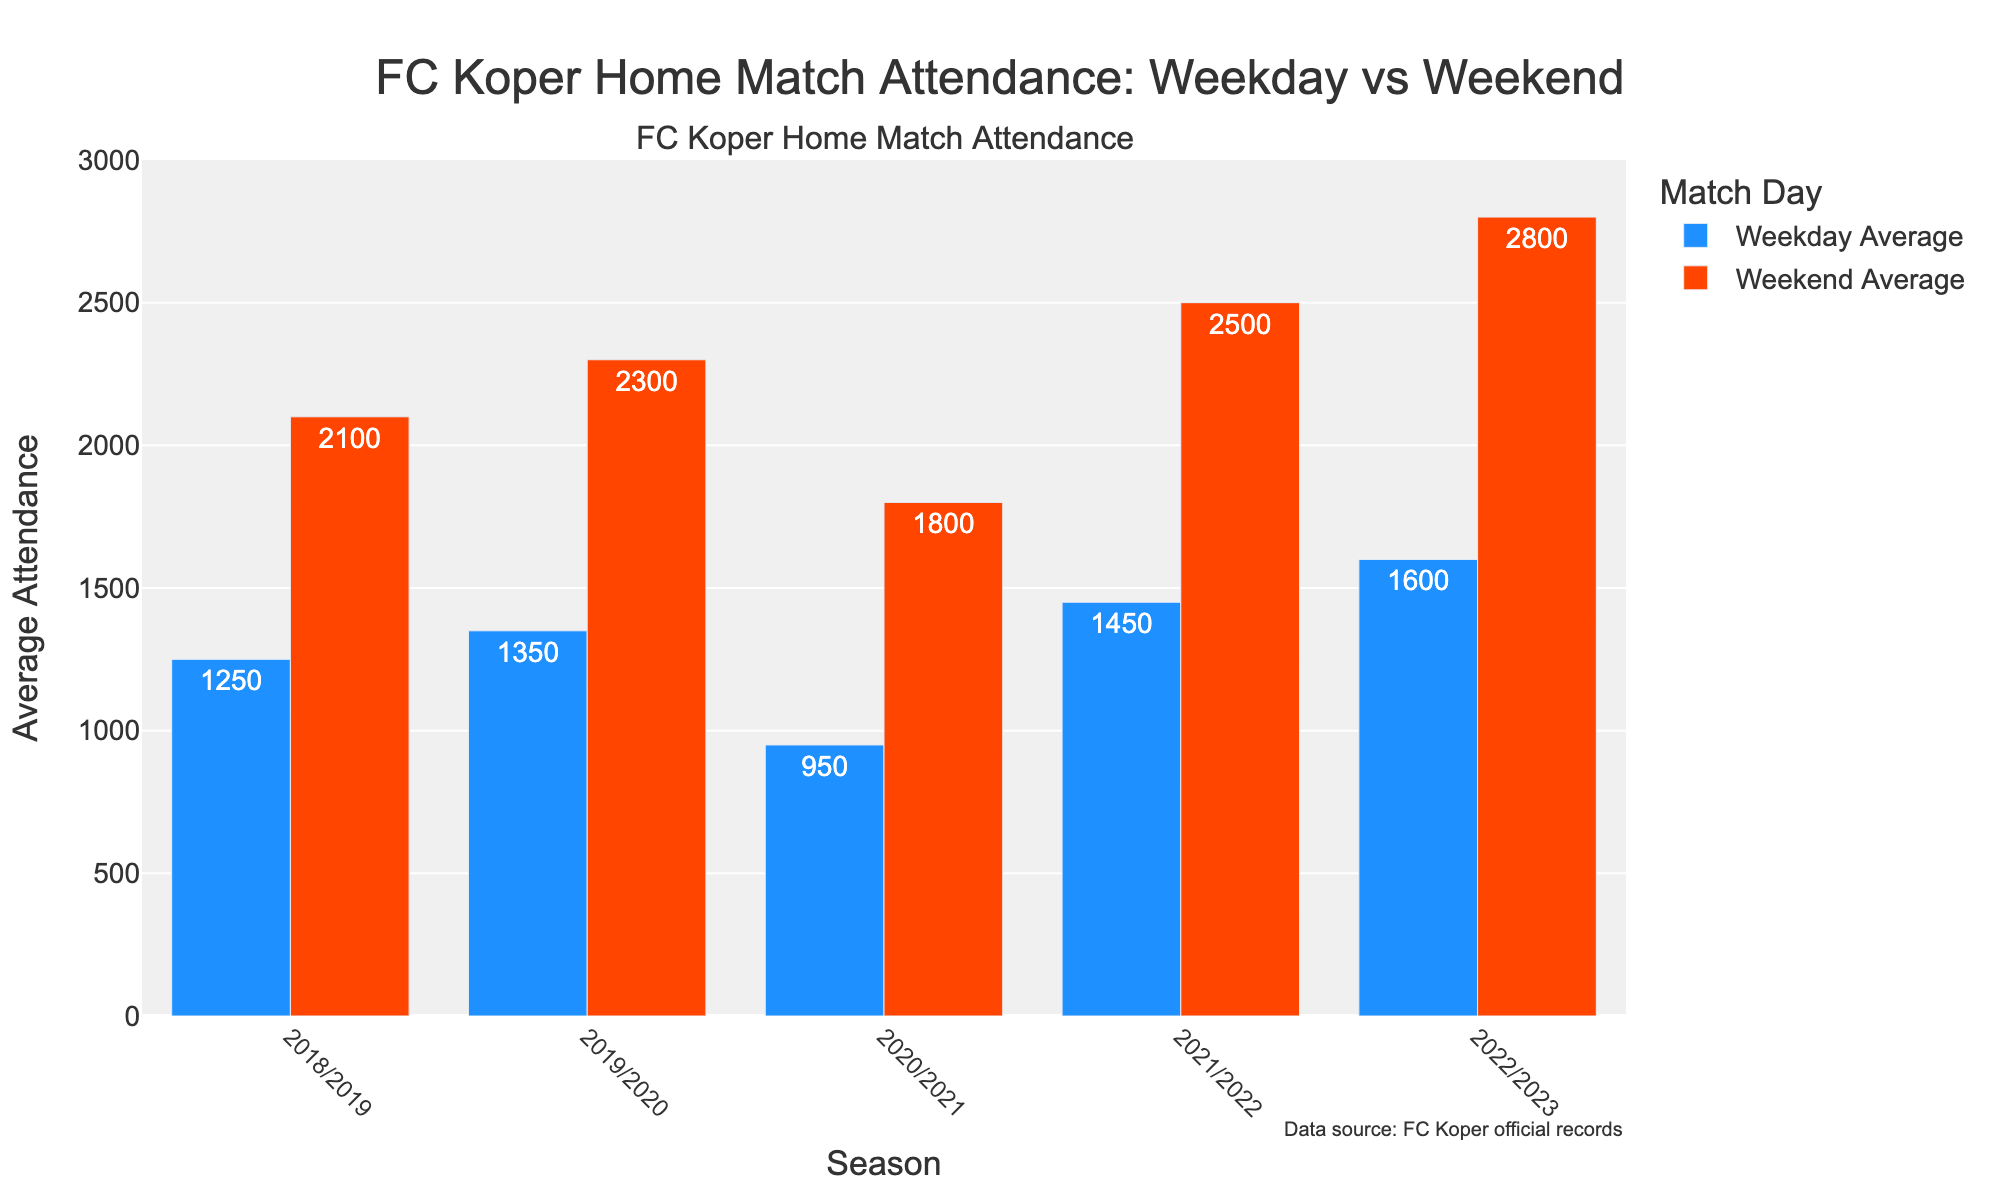What's the average attendance for FC Koper's home matches on weekdays in the 2022/2023 season? The bar corresponding to the 'Weekday Average' for the 2022/2023 season reaches up to 1600.
Answer: 1600 In which season did FC Koper record the highest weekend attendance? By comparing the heights of the 'Weekend Average' bars across all seasons, the 2022/2023 season has the highest bar at 2800.
Answer: 2022/2023 By how much did the weekday average attendance increase from the 2020/2021 to the 2022/2023 season? Subtract the 'Weekday Average' for 2020/2021 (950) from the 'Weekday Average' for 2022/2023 (1600). 1600 - 950 = 650.
Answer: 650 Which season had the smallest difference between weekday and weekend average attendance? Calculate the difference between 'Weekday Average' and 'Weekend Average' for each season. The smallest difference is in the 2018/2019 season: 2100 - 1250 = 850.
Answer: 2018/2019 How did the average weekend attendance change from the 2018/2019 season to the 2021/2022 season? Compare the weekend averages for these two seasons: 2100 in 2018/2019 and 2500 in 2021/2022. The increase is 2500 - 2100 = 400.
Answer: Increased by 400 Were there any seasons where the average weekend attendance was less than double the average weekday attendance? Calculate for each season if 'Weekend Average' < 2 * 'Weekday Average'. For 2020/2021: 1800 is less than 2 * 950 (1900), thus 'yes'.
Answer: Yes, 2020/2021 What is the average weekend attendance over the five seasons? Sum the 'Weekend Average' values for all seasons and divide by 5: (2100 + 2300 + 1800 + 2500 + 2800) / 5 = 11500 / 5 = 2300.
Answer: 2300 Is there a season where the average attendance for both weekday and weekend games increased compared to the previous season? Compare both 'Weekday Average' and 'Weekend Average' for sequential seasons. Both increased from 2020/2021 (950/1800) to 2021/2022 (1450/2500).
Answer: Yes, 2021/2022 